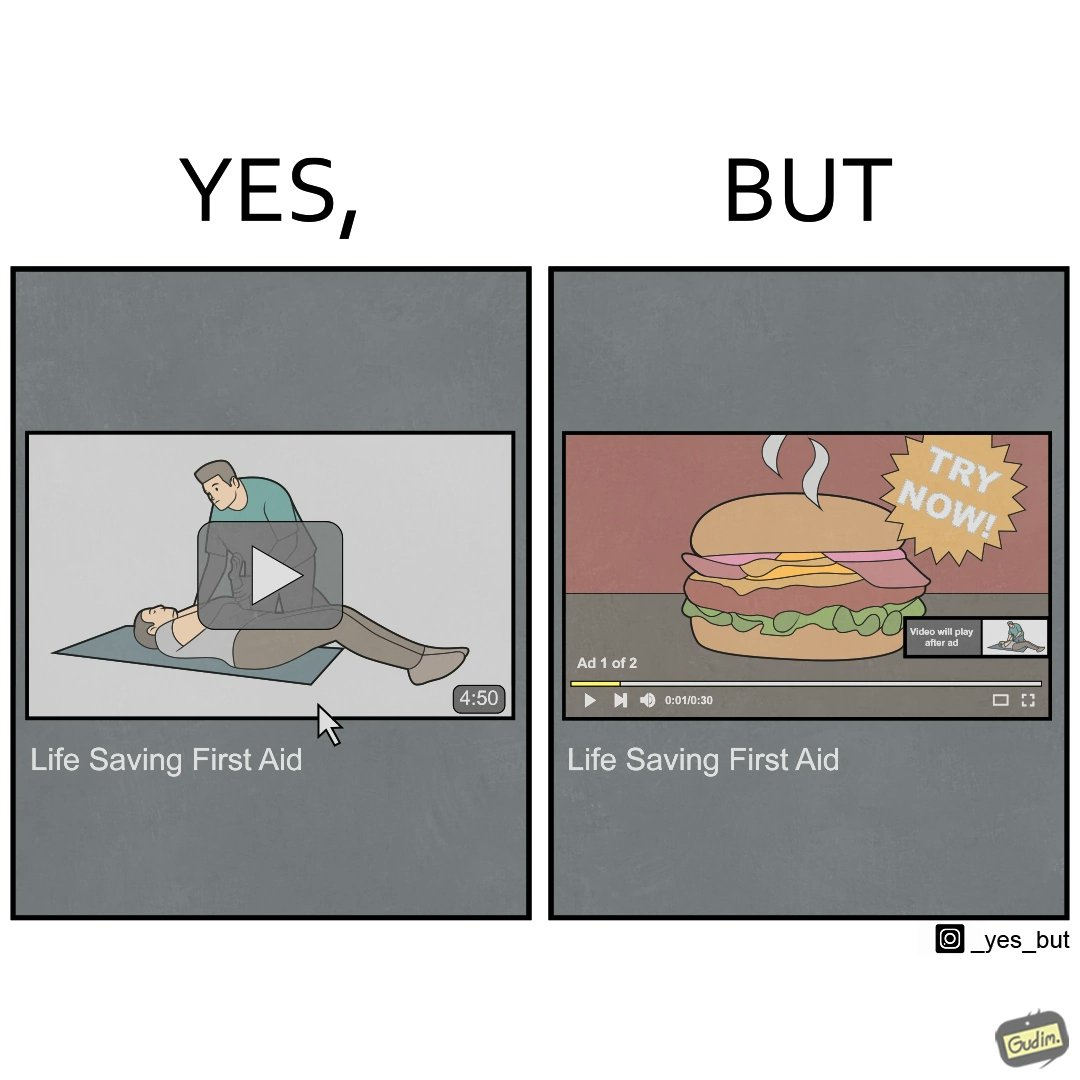Is there satirical content in this image? Yes, this image is satirical. 